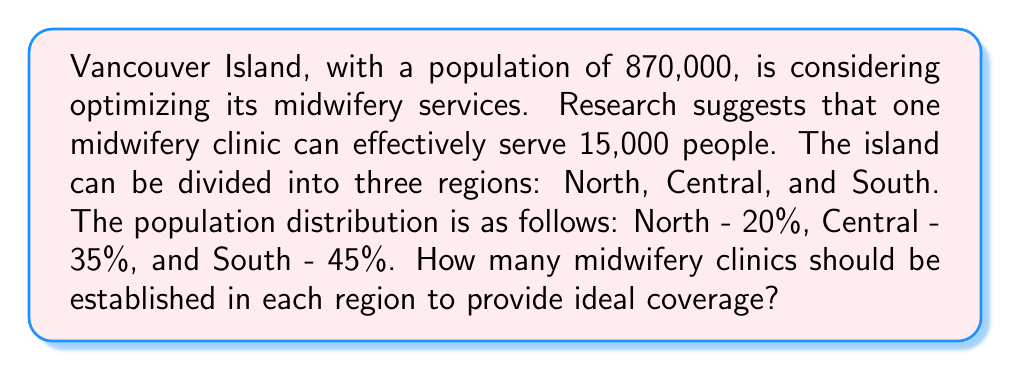Solve this math problem. To solve this problem, we'll follow these steps:

1. Calculate the total number of clinics needed for the entire island:
   $$\text{Total clinics} = \frac{\text{Total population}}{\text{People served per clinic}}$$
   $$\text{Total clinics} = \frac{870,000}{15,000} = 58$$

2. Calculate the population for each region:
   North: $870,000 \times 20\% = 174,000$
   Central: $870,000 \times 35\% = 304,500$
   South: $870,000 \times 45\% = 391,500$

3. Calculate the number of clinics needed for each region:
   North: $\frac{174,000}{15,000} = 11.6$
   Central: $\frac{304,500}{15,000} = 20.3$
   South: $\frac{391,500}{15,000} = 26.1$

4. Round the results to the nearest whole number:
   North: 12 clinics
   Central: 20 clinics
   South: 26 clinics

Note that the sum of these rounded numbers (58) matches the total number of clinics calculated in step 1, ensuring an ideal distribution across the island.
Answer: The ideal distribution of midwifery clinics across Vancouver Island is:
North region: 12 clinics
Central region: 20 clinics
South region: 26 clinics 